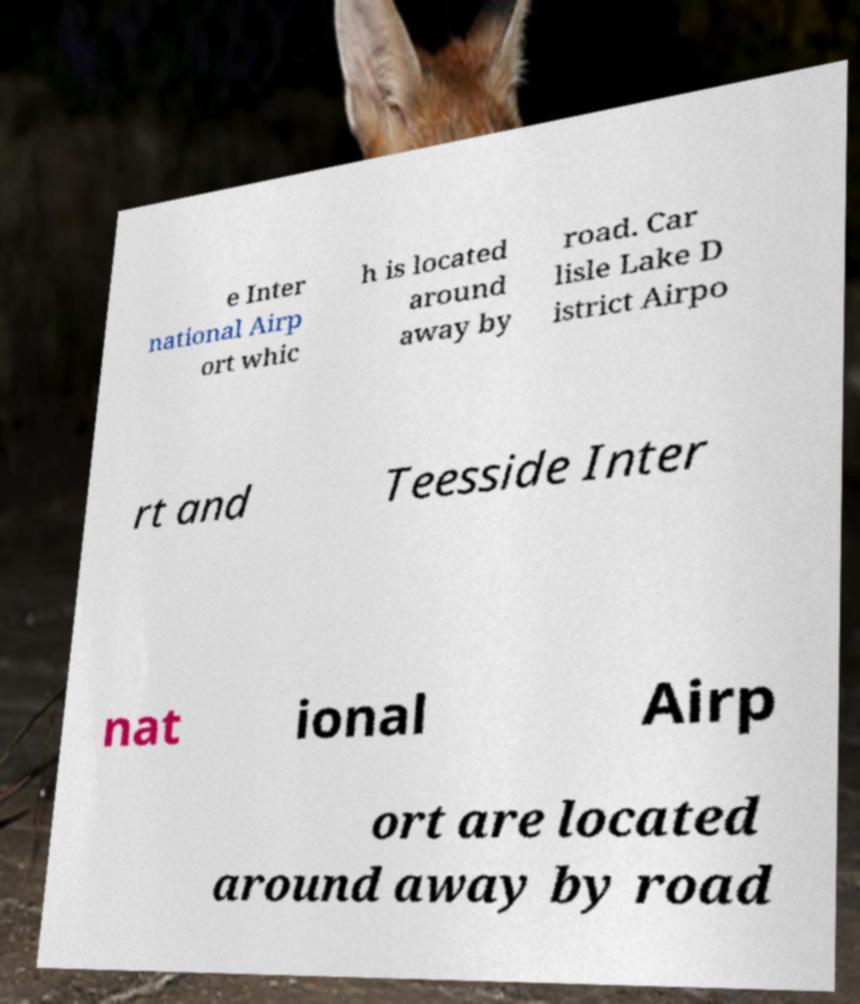Could you assist in decoding the text presented in this image and type it out clearly? e Inter national Airp ort whic h is located around away by road. Car lisle Lake D istrict Airpo rt and Teesside Inter nat ional Airp ort are located around away by road 